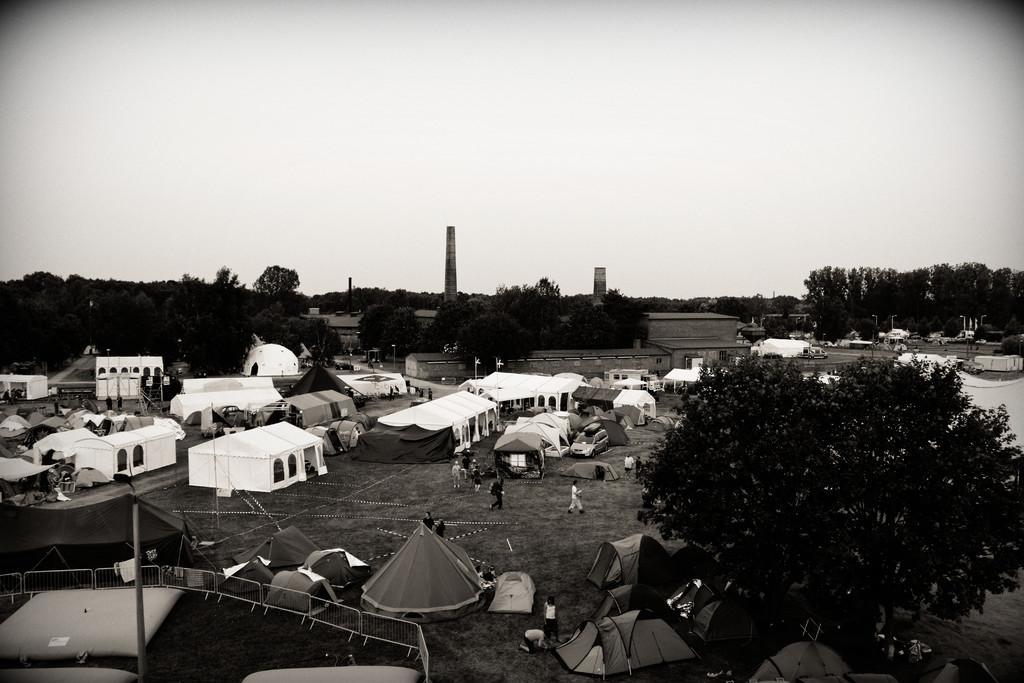In one or two sentences, can you explain what this image depicts? In this picture we can see tree, tents, fence and poles. There are people and we can see car. In the background of the image we can see houses, trees, poles and sky. 